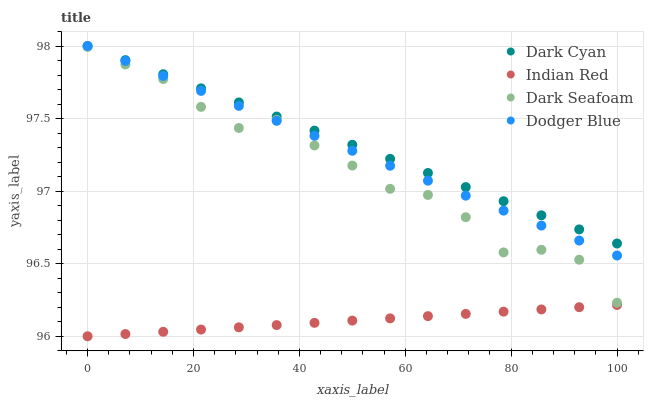Does Indian Red have the minimum area under the curve?
Answer yes or no. Yes. Does Dark Cyan have the maximum area under the curve?
Answer yes or no. Yes. Does Dark Seafoam have the minimum area under the curve?
Answer yes or no. No. Does Dark Seafoam have the maximum area under the curve?
Answer yes or no. No. Is Indian Red the smoothest?
Answer yes or no. Yes. Is Dark Seafoam the roughest?
Answer yes or no. Yes. Is Dodger Blue the smoothest?
Answer yes or no. No. Is Dodger Blue the roughest?
Answer yes or no. No. Does Indian Red have the lowest value?
Answer yes or no. Yes. Does Dark Seafoam have the lowest value?
Answer yes or no. No. Does Dodger Blue have the highest value?
Answer yes or no. Yes. Does Dark Seafoam have the highest value?
Answer yes or no. No. Is Indian Red less than Dark Seafoam?
Answer yes or no. Yes. Is Dark Cyan greater than Dark Seafoam?
Answer yes or no. Yes. Does Dark Cyan intersect Dodger Blue?
Answer yes or no. Yes. Is Dark Cyan less than Dodger Blue?
Answer yes or no. No. Is Dark Cyan greater than Dodger Blue?
Answer yes or no. No. Does Indian Red intersect Dark Seafoam?
Answer yes or no. No. 